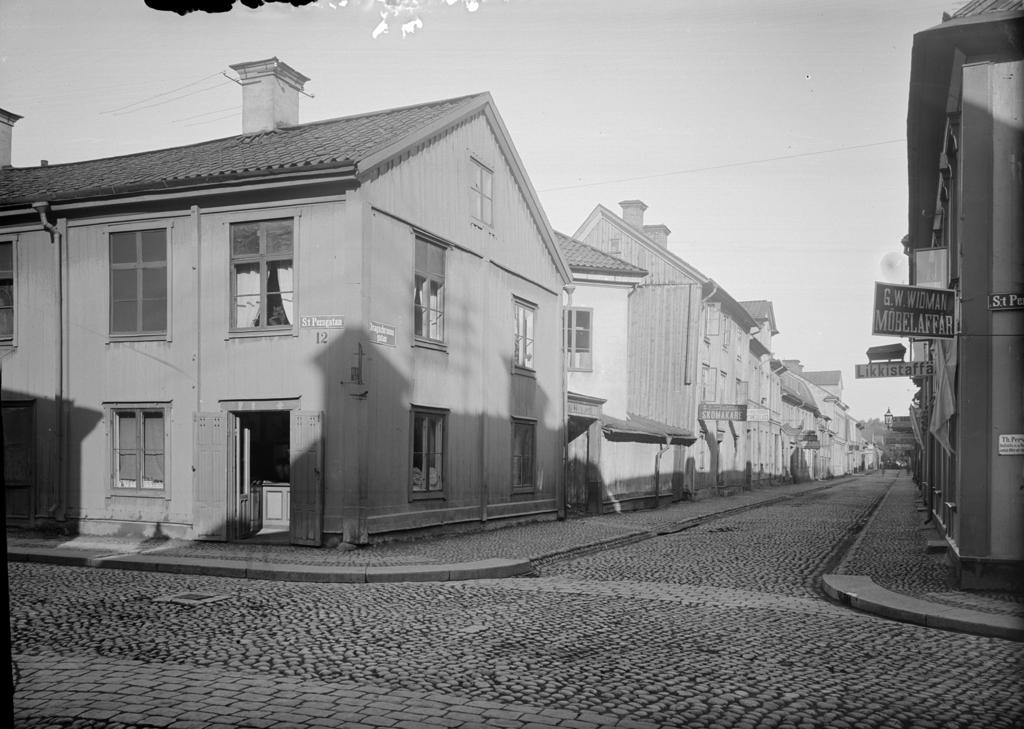What is the color scheme of the image? The image is black and white. What can be seen in the center of the image? There are houses in the center of the image. What is a feature of the image that allows for transportation? There is a road in the image. Where are more houses located in the image? There are houses at the right side of the image. Is there a woman standing in the quicksand in the image? There is no quicksand or woman present in the image. What type of advertisement can be seen on the houses in the image? There is no advertisement visible on the houses in the image; it is a black and white image with no text or additional details. 